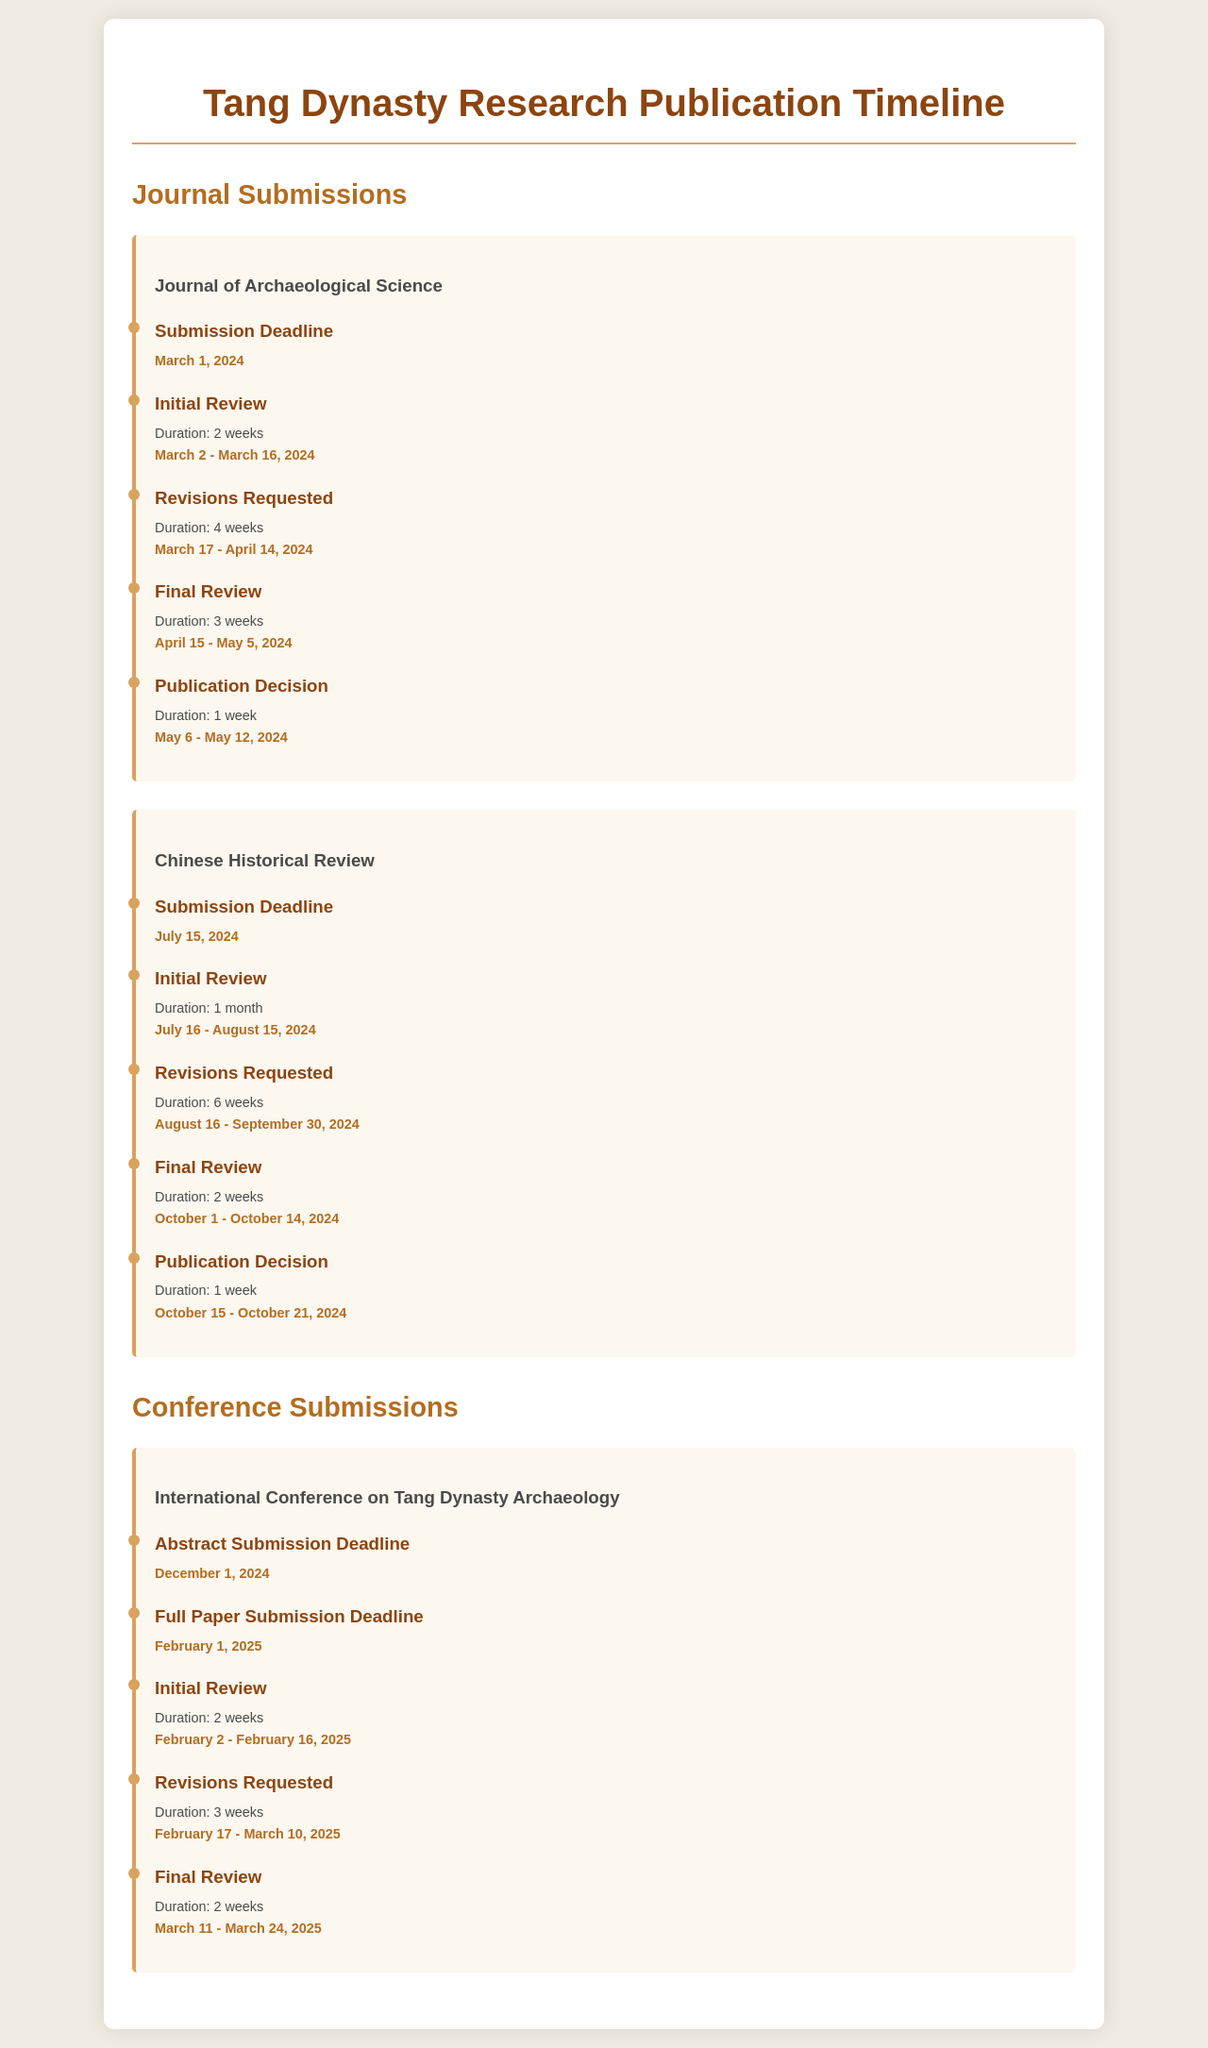What is the submission deadline for the Journal of Archaeological Science? The submission deadline for the Journal of Archaeological Science is specified in the document, which is March 1, 2024.
Answer: March 1, 2024 What is the duration of the initial review for the Chinese Historical Review? The duration of the initial review for the Chinese Historical Review is detailed in the timeline, which is 1 month.
Answer: 1 month When does the final review for the International Conference on Tang Dynasty Archaeology start? The document states the start date for the final review for the International Conference on Tang Dynasty Archaeology, which is March 11, 2025.
Answer: March 11, 2025 How long is the revision period for the Journal of Archaeological Science? The revision period for the Journal of Archaeological Science is given in the document, which is 4 weeks.
Answer: 4 weeks What is the publication decision duration for the Chinese Historical Review? The publication decision duration for the Chinese Historical Review is stated as 1 week in the timeline.
Answer: 1 week What is the abstract submission deadline for the International Conference on Tang Dynasty Archaeology? The abstract submission deadline for the International Conference on Tang Dynasty Archaeology is mentioned in the document as December 1, 2024.
Answer: December 1, 2024 How many weeks does the final review for the Journal of Archaeological Science last? The document outlines the duration of the final review for the Journal of Archaeological Science, which lasts for 3 weeks.
Answer: 3 weeks What is the title of the first journal listed in the publication timeline? The document lists the first journal under Journal Submissions as the Journal of Archaeological Science.
Answer: Journal of Archaeological Science When does the initial review for the Chinese Historical Review end? The document specifies the end date for the initial review for the Chinese Historical Review, which is August 15, 2024.
Answer: August 15, 2024 